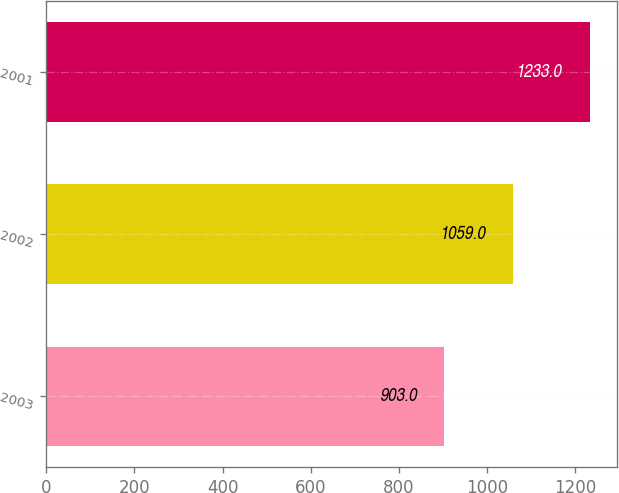Convert chart. <chart><loc_0><loc_0><loc_500><loc_500><bar_chart><fcel>2003<fcel>2002<fcel>2001<nl><fcel>903<fcel>1059<fcel>1233<nl></chart> 